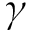<formula> <loc_0><loc_0><loc_500><loc_500>\gamma</formula> 